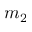Convert formula to latex. <formula><loc_0><loc_0><loc_500><loc_500>m _ { 2 }</formula> 